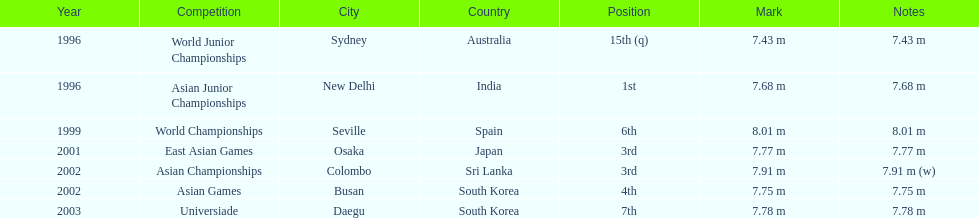How many times did his jump surpass 7.70 m? 5. 